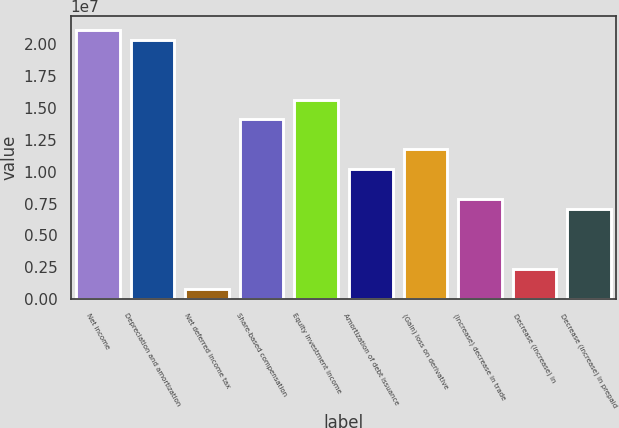Convert chart. <chart><loc_0><loc_0><loc_500><loc_500><bar_chart><fcel>Net income<fcel>Depreciation and amortization<fcel>Net deferred income tax<fcel>Share-based compensation<fcel>Equity investment income<fcel>Amortization of debt issuance<fcel>(Gain) loss on derivative<fcel>(Increase) decrease in trade<fcel>Decrease (increase) in<fcel>Decrease (increase) in prepaid<nl><fcel>2.11525e+07<fcel>2.03691e+07<fcel>784681<fcel>1.41021e+07<fcel>1.56689e+07<fcel>1.01852e+07<fcel>1.1752e+07<fcel>7.83509e+06<fcel>2.35144e+06<fcel>7.05171e+06<nl></chart> 